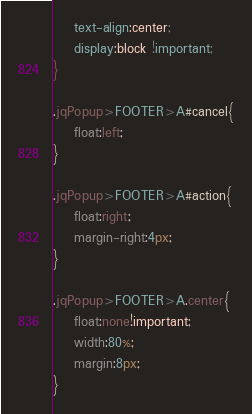Convert code to text. <code><loc_0><loc_0><loc_500><loc_500><_CSS_>    text-align:center;
    display:block !important;
}

.jqPopup>FOOTER>A#cancel{
    float:left;
}

.jqPopup>FOOTER>A#action{
    float:right;
    margin-right:4px;
}

.jqPopup>FOOTER>A.center{
    float:none!important;
    width:80%;
    margin:8px;
}</code> 